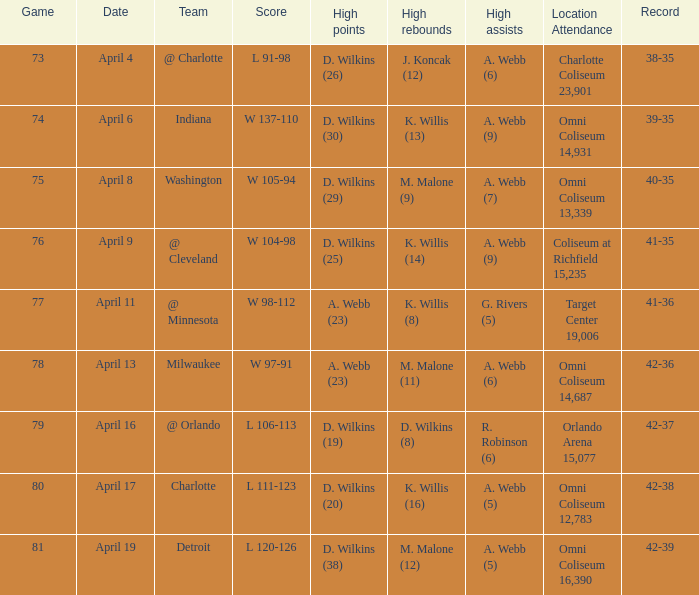What was the venue and number of attendees when they performed in milwaukee? Omni Coliseum 14,687. 